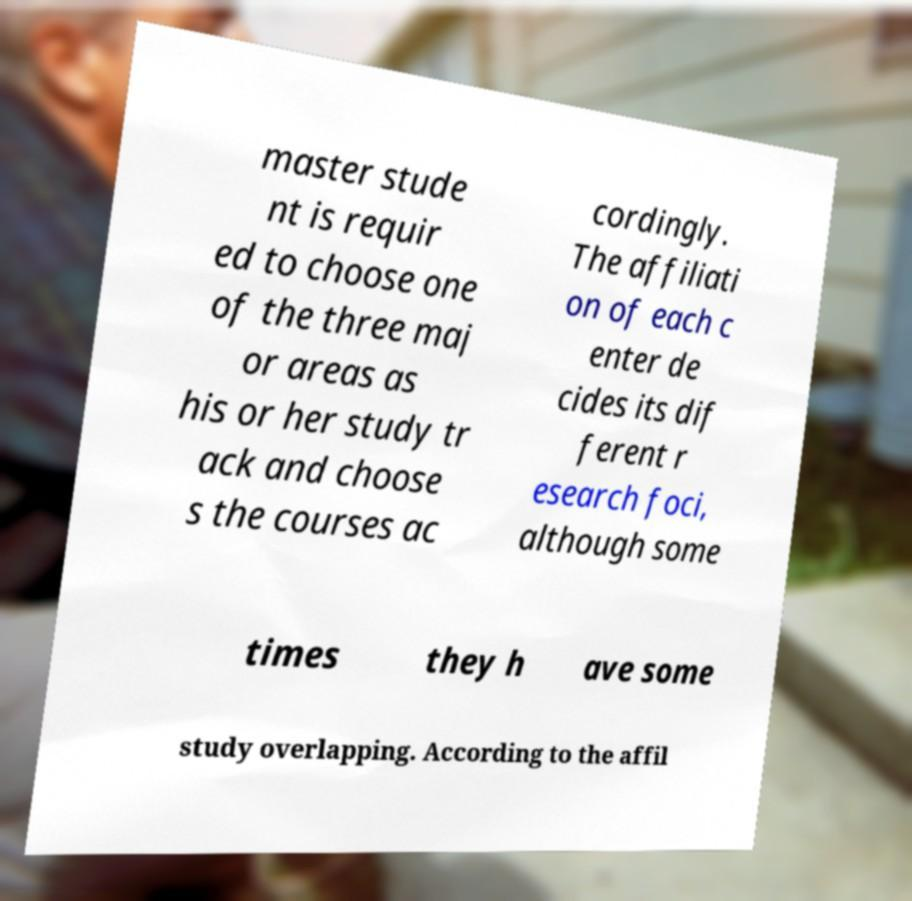Please read and relay the text visible in this image. What does it say? master stude nt is requir ed to choose one of the three maj or areas as his or her study tr ack and choose s the courses ac cordingly. The affiliati on of each c enter de cides its dif ferent r esearch foci, although some times they h ave some study overlapping. According to the affil 